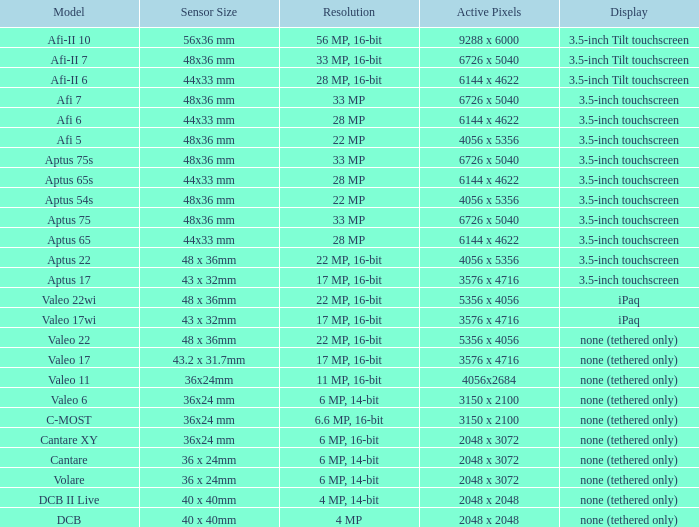What is the resolution of the camera that has 6726 x 5040 pixels and a model of afi 7? 33 MP. 